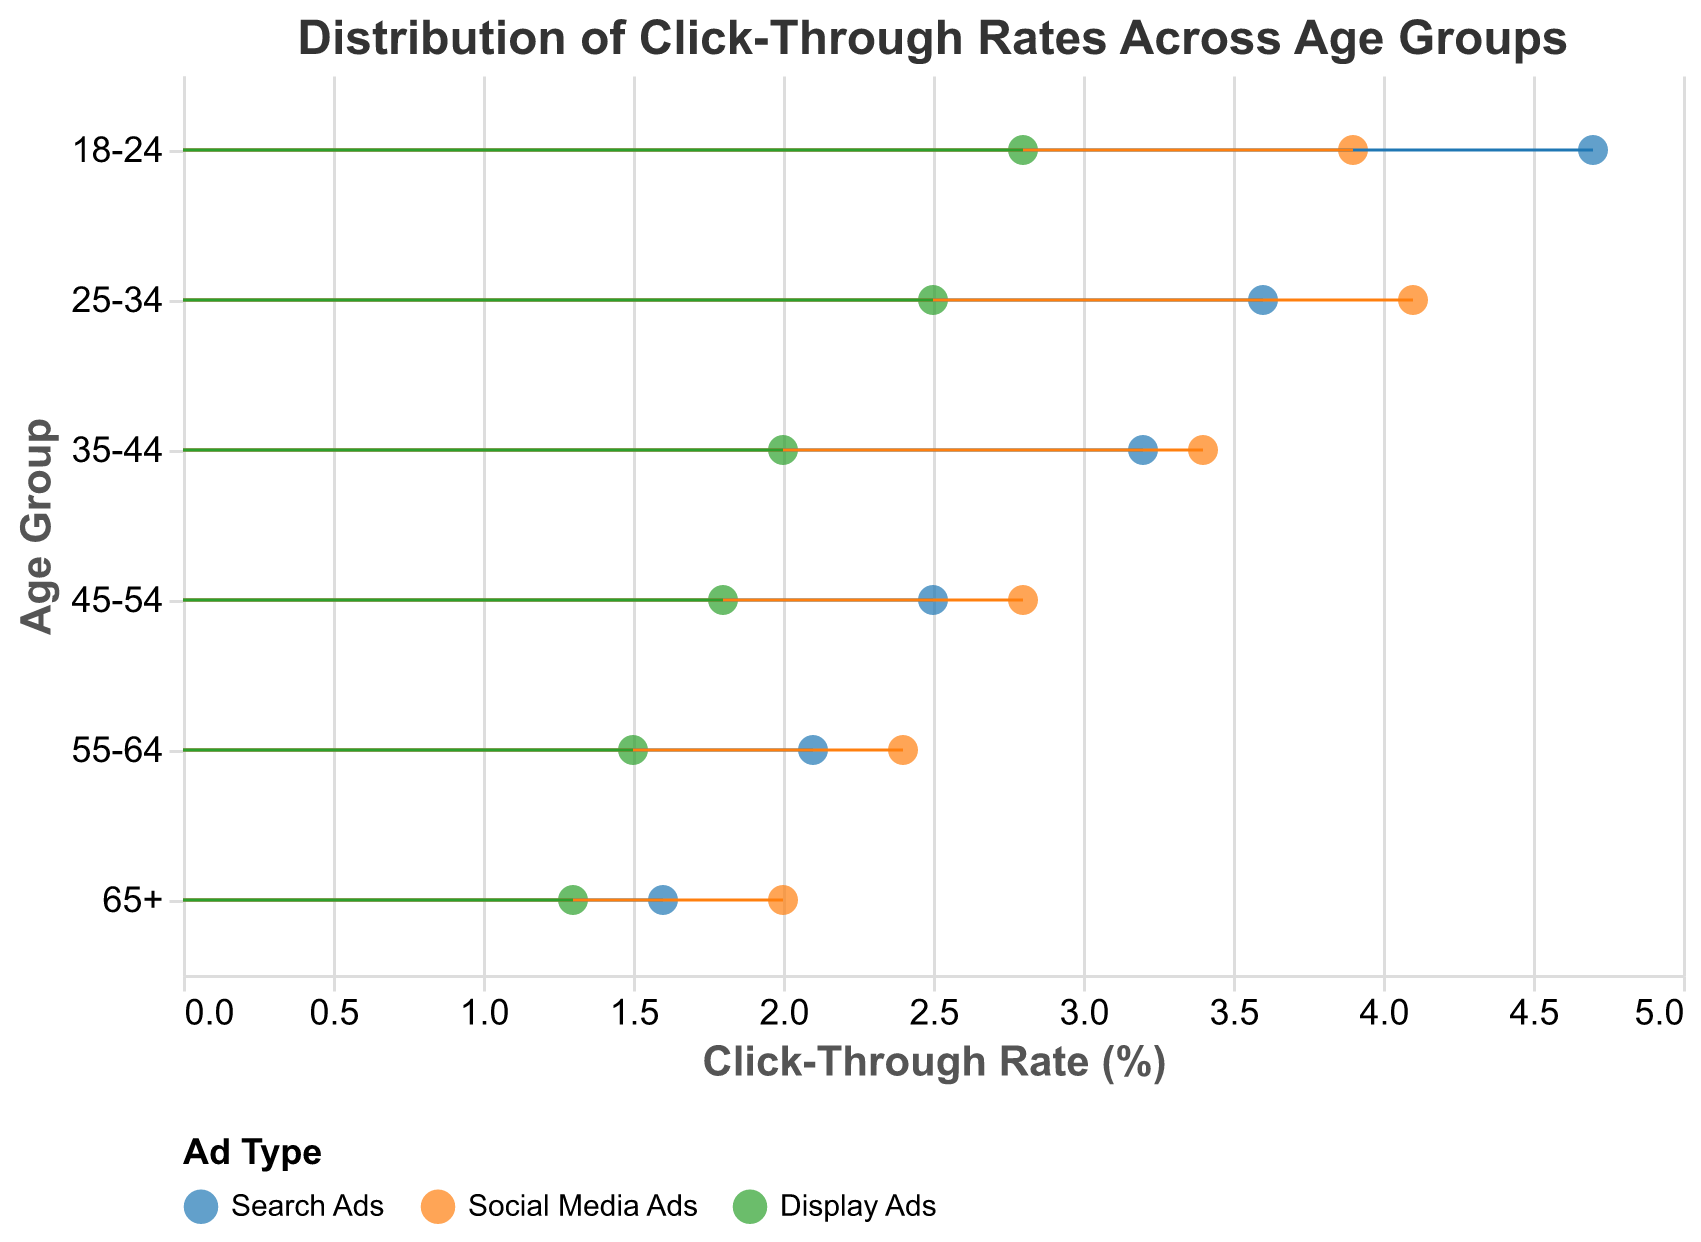How many data points are there in total? The plot shows data points for each combination of age group and ad type. There are 6 age groups and 3 ad types, resulting in 6 * 3 = 18 data points in total.
Answer: 18 Which age group has the highest click-through rate for Search Ads? By examining the height of the points corresponding to "Search Ads" for each age group, the highest Click-Through Rate (%) is for the 18-24 age group with a CTR of 4.7%.
Answer: 18-24 What is the average Click-Through Rate (%) for Display Ads across all age groups? To find the average: add all the click-through rates for Display Ads (2.8, 2.5, 2.0, 1.8, 1.5, 1.3) and then divide by the number of groups (6). (2.8 + 2.5 + 2.0 + 1.8 + 1.5 + 1.3) / 6 = 12.9 / 6 = 2.15. Note that the units are in %.
Answer: 2.15 What trend can we observe in Click-Through Rates (%) for Search Ads as age increases? Observing the points for Search Ads across the different age groups, the click-through rate shows a decreasing trend as the age group increases, from 4.7% for 18-24 down to 1.6% for 65+.
Answer: Decreasing Which ad type has the most consistent Click-Through Rates (%) across all age groups? The consistency of the click-through rates can be observed by the tightness of the spread for a given ad type. Social Media Ads show the smallest variation in click-through rates (from 3.9% to 2.0%) compared to Search Ads and Display Ads, which have larger ranges.
Answer: Social Media Ads What is the Click-Through Rate (%) for 25-34 age group for each ad type? The values can be directly picked from the data points as shown in the plot: Search Ads: 3.6%, Social Media Ads: 4.1%, Display Ads: 2.5%.
Answer: Search Ads: 3.6%, Social Media Ads: 4.1%, Display Ads: 2.5% Which age group has the lowest click-through rate for Display Ads? By examining the points for Display Ads across age groups, the lowest Click-Through Rate (%) is for the 65+ age group with a CTR of 1.3%.
Answer: 65+ 